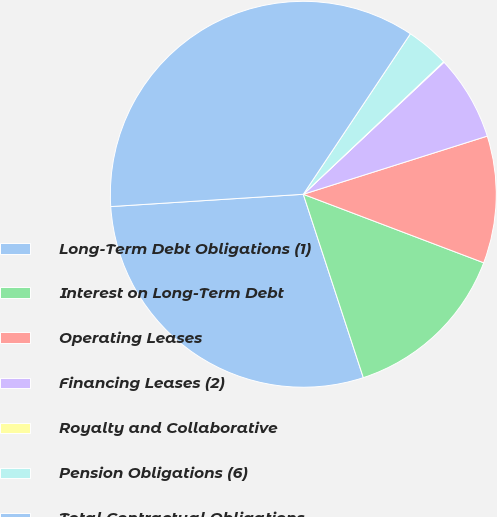<chart> <loc_0><loc_0><loc_500><loc_500><pie_chart><fcel>Long-Term Debt Obligations (1)<fcel>Interest on Long-Term Debt<fcel>Operating Leases<fcel>Financing Leases (2)<fcel>Royalty and Collaborative<fcel>Pension Obligations (6)<fcel>Total Contractual Obligations<nl><fcel>29.02%<fcel>14.19%<fcel>10.65%<fcel>7.12%<fcel>0.05%<fcel>3.59%<fcel>35.38%<nl></chart> 